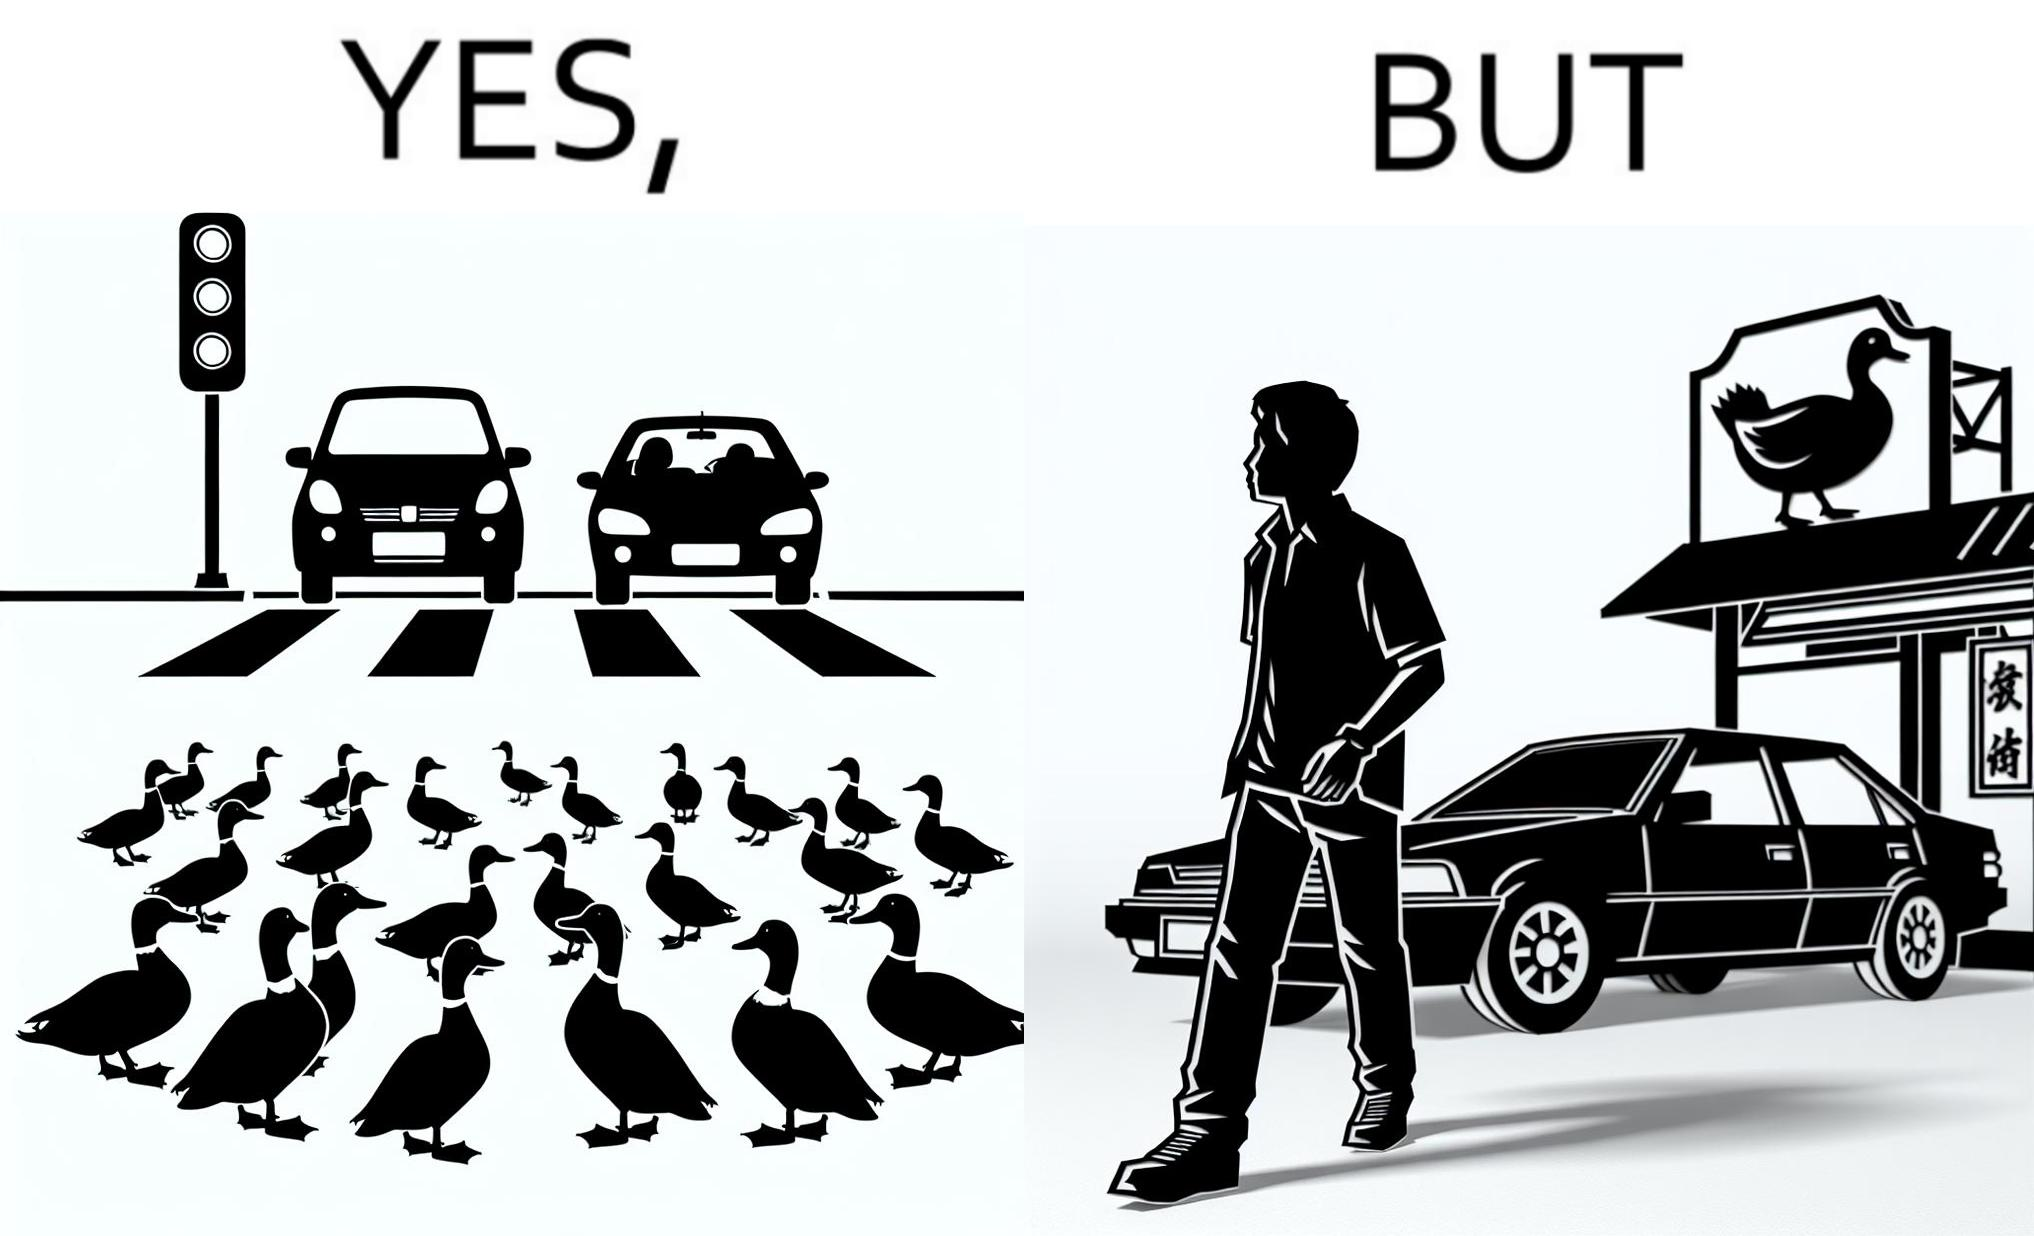Why is this image considered satirical? The images are ironic since they show how a man supposedly cares for ducks since he stops his vehicle to give way to queue of ducks allowing them to safely cross a road but on the other hand he goes to a peking duck shop to buy and eat similar ducks after having them killed 